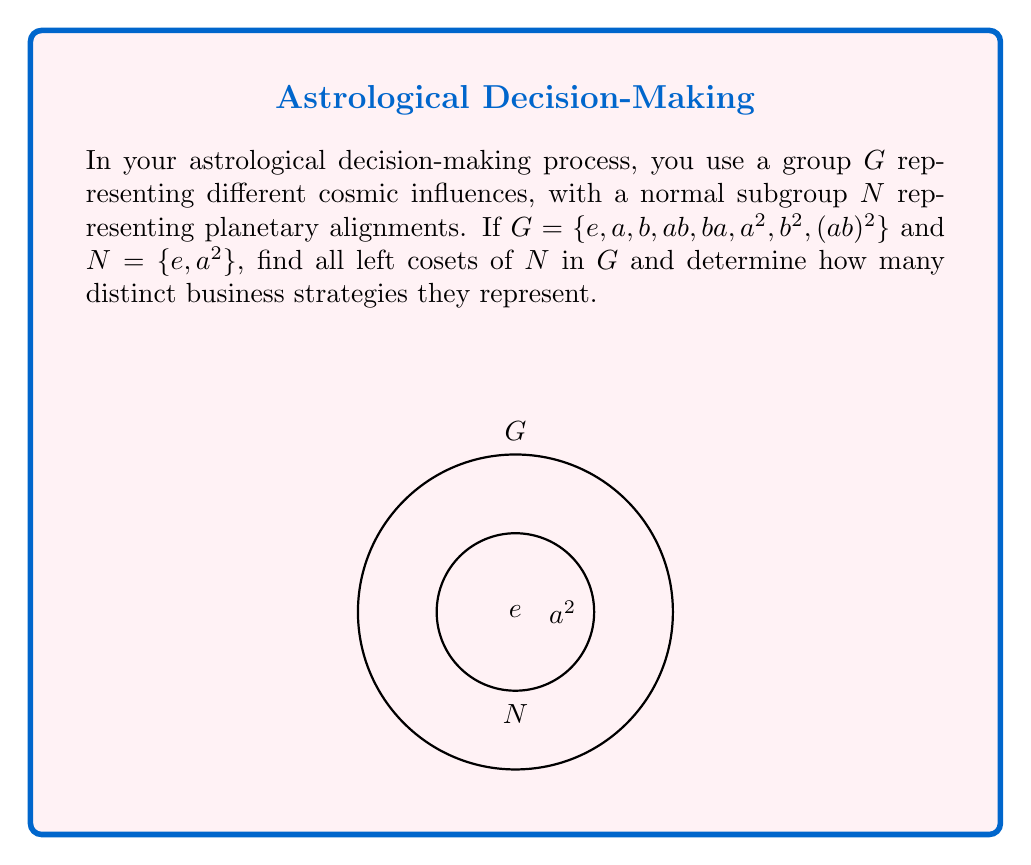Help me with this question. Let's approach this step-by-step:

1) First, recall that for a normal subgroup $N$ of $G$, the left cosets are the same as the right cosets.

2) To find the cosets, we multiply $N$ by each element of $G$ on the left:

   $eN = \{e, a^2\}$
   $aN = \{a, a^3\} = \{a, a\}$ (since $a^3 = a$ in this group)
   $bN = \{b, ba^2\}$
   $abN = \{ab, aba^2\}$
   $baN = \{ba, baa^2\}$
   $a^2N = \{a^2, a^4\} = \{a^2, e\} = N$
   $b^2N = \{b^2, b^2a^2\}$
   $(ab)^2N = \{(ab)^2, (ab)^2a^2\}$

3) Now, we need to identify which of these are distinct:

   $eN = a^2N = N = \{e, a^2\}$
   $aN = \{a, a\}$
   $bN = \{b, ba^2\}$
   $abN = \{ab, aba^2\}$
   $baN = \{ba, baa^2\}$
   $b^2N = \{b^2, b^2a^2\}$
   $(ab)^2N = \{(ab)^2, (ab)^2a^2\}$

4) We can see that there are 7 distinct cosets.

5) In the context of business strategies, each coset represents a distinct approach influenced by different cosmic alignments. The number of cosets corresponds to the number of unique strategies available.
Answer: 7 distinct cosets, representing 7 unique business strategies. 